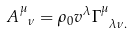<formula> <loc_0><loc_0><loc_500><loc_500>A _ { \ \nu } ^ { \mu } = \rho _ { 0 } v ^ { \lambda } \Gamma _ { \ \lambda \nu . } ^ { \mu }</formula> 